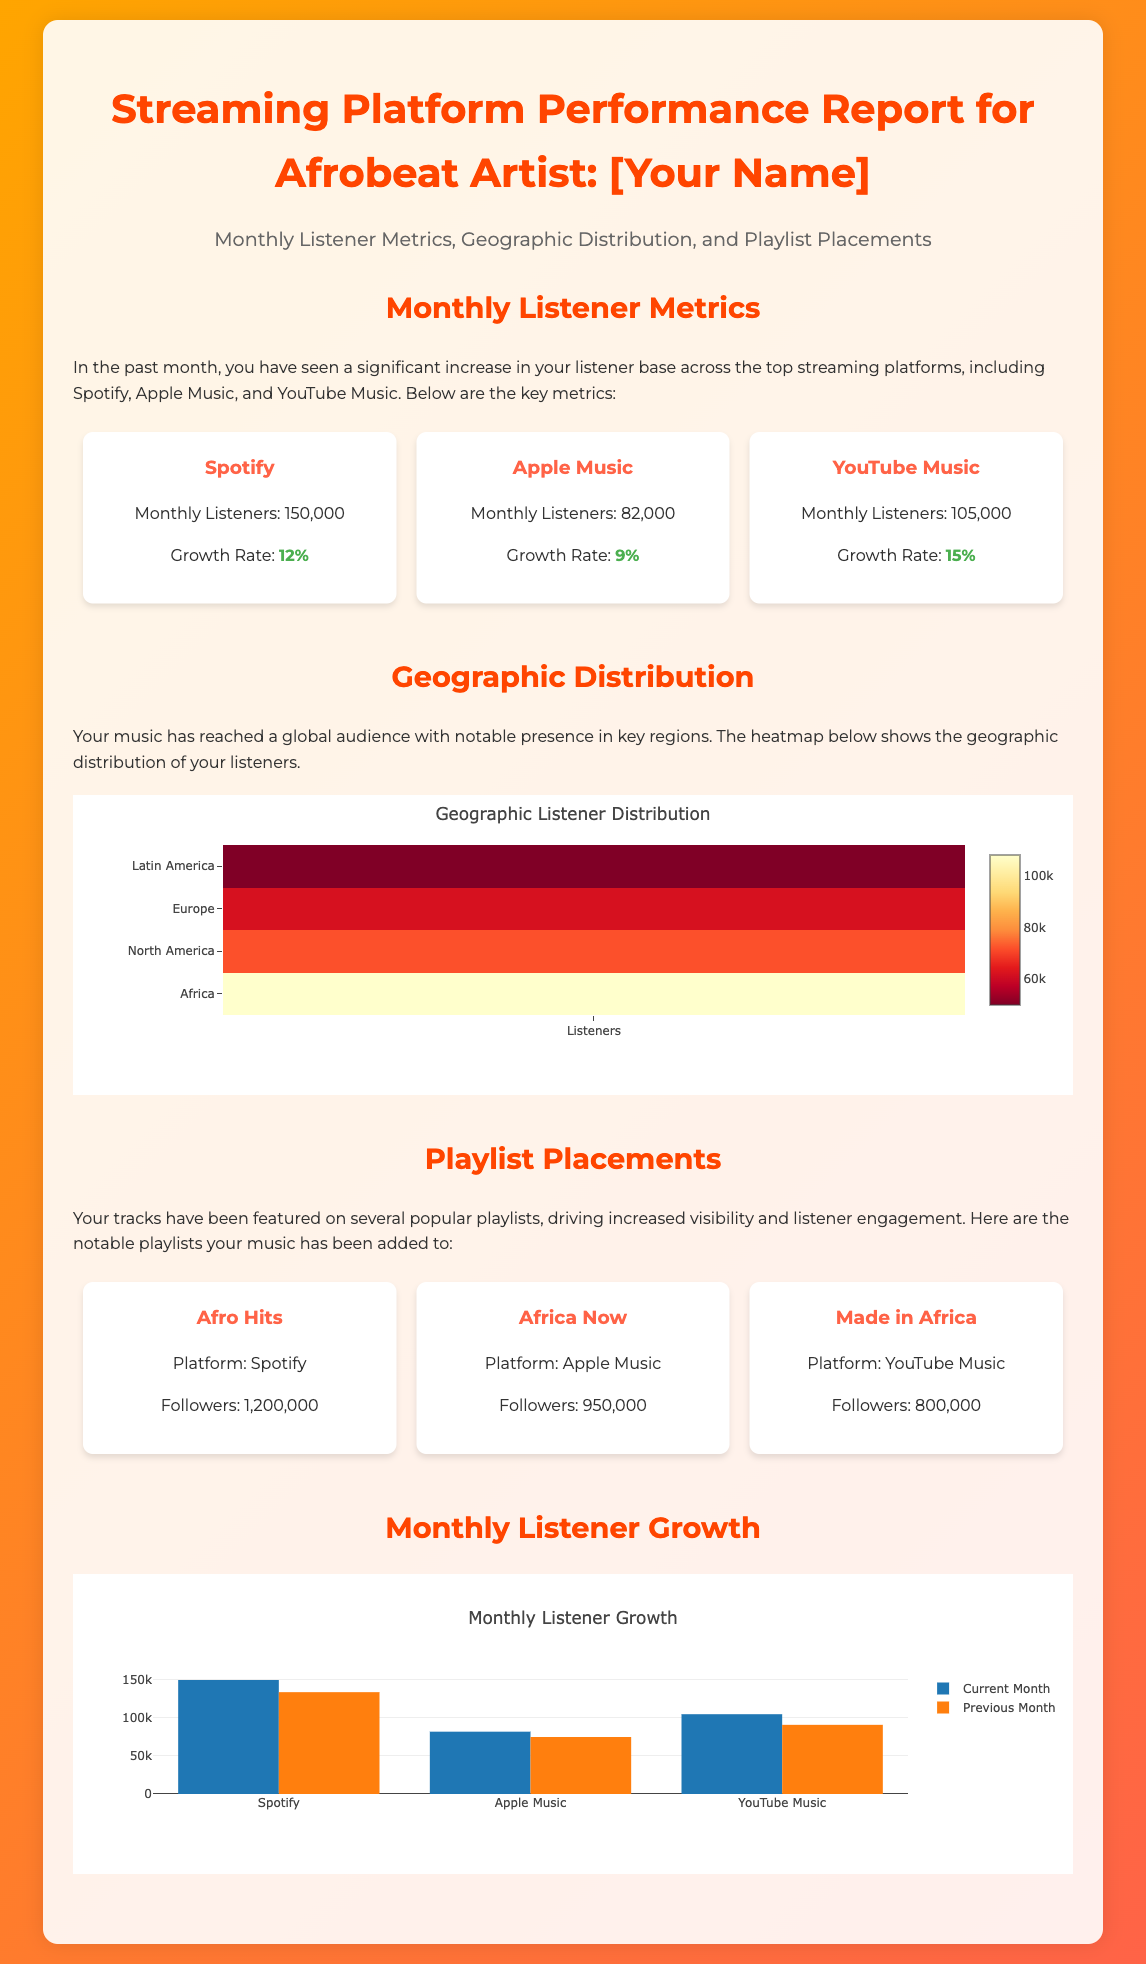What is the monthly listeners count on Spotify? The document states that the monthly listeners on Spotify is 150,000.
Answer: 150,000 What is the growth rate for Apple Music? The document specifies that the growth rate for Apple Music is 9%.
Answer: 9% Which geographic region has the highest number of listeners? Based on the heatmap data provided, Africa has the highest number of listeners at 108,000.
Answer: Africa How many followers does the "Afro Hits" playlist have? The document mentions that the "Afro Hits" playlist has 1,200,000 followers.
Answer: 1,200,000 What was the previous month's listener count on YouTube Music? The document indicates that the previous month's listener count on YouTube Music was 91,000.
Answer: 91,000 Which streaming platform has the highest current monthly listeners? According to the metrics, Spotify has the highest current monthly listeners at 150,000.
Answer: Spotify What is the total number of platforms mentioned in the document? The document mentions three platforms: Spotify, Apple Music, and YouTube Music.
Answer: Three What type of chart is used to visualize monthly listener growth? The document specifies that a bar chart is used to visualize monthly listener growth.
Answer: Bar chart Which playlist is featured on Apple Music? The document states that the "Africa Now" playlist is featured on Apple Music.
Answer: Africa Now 